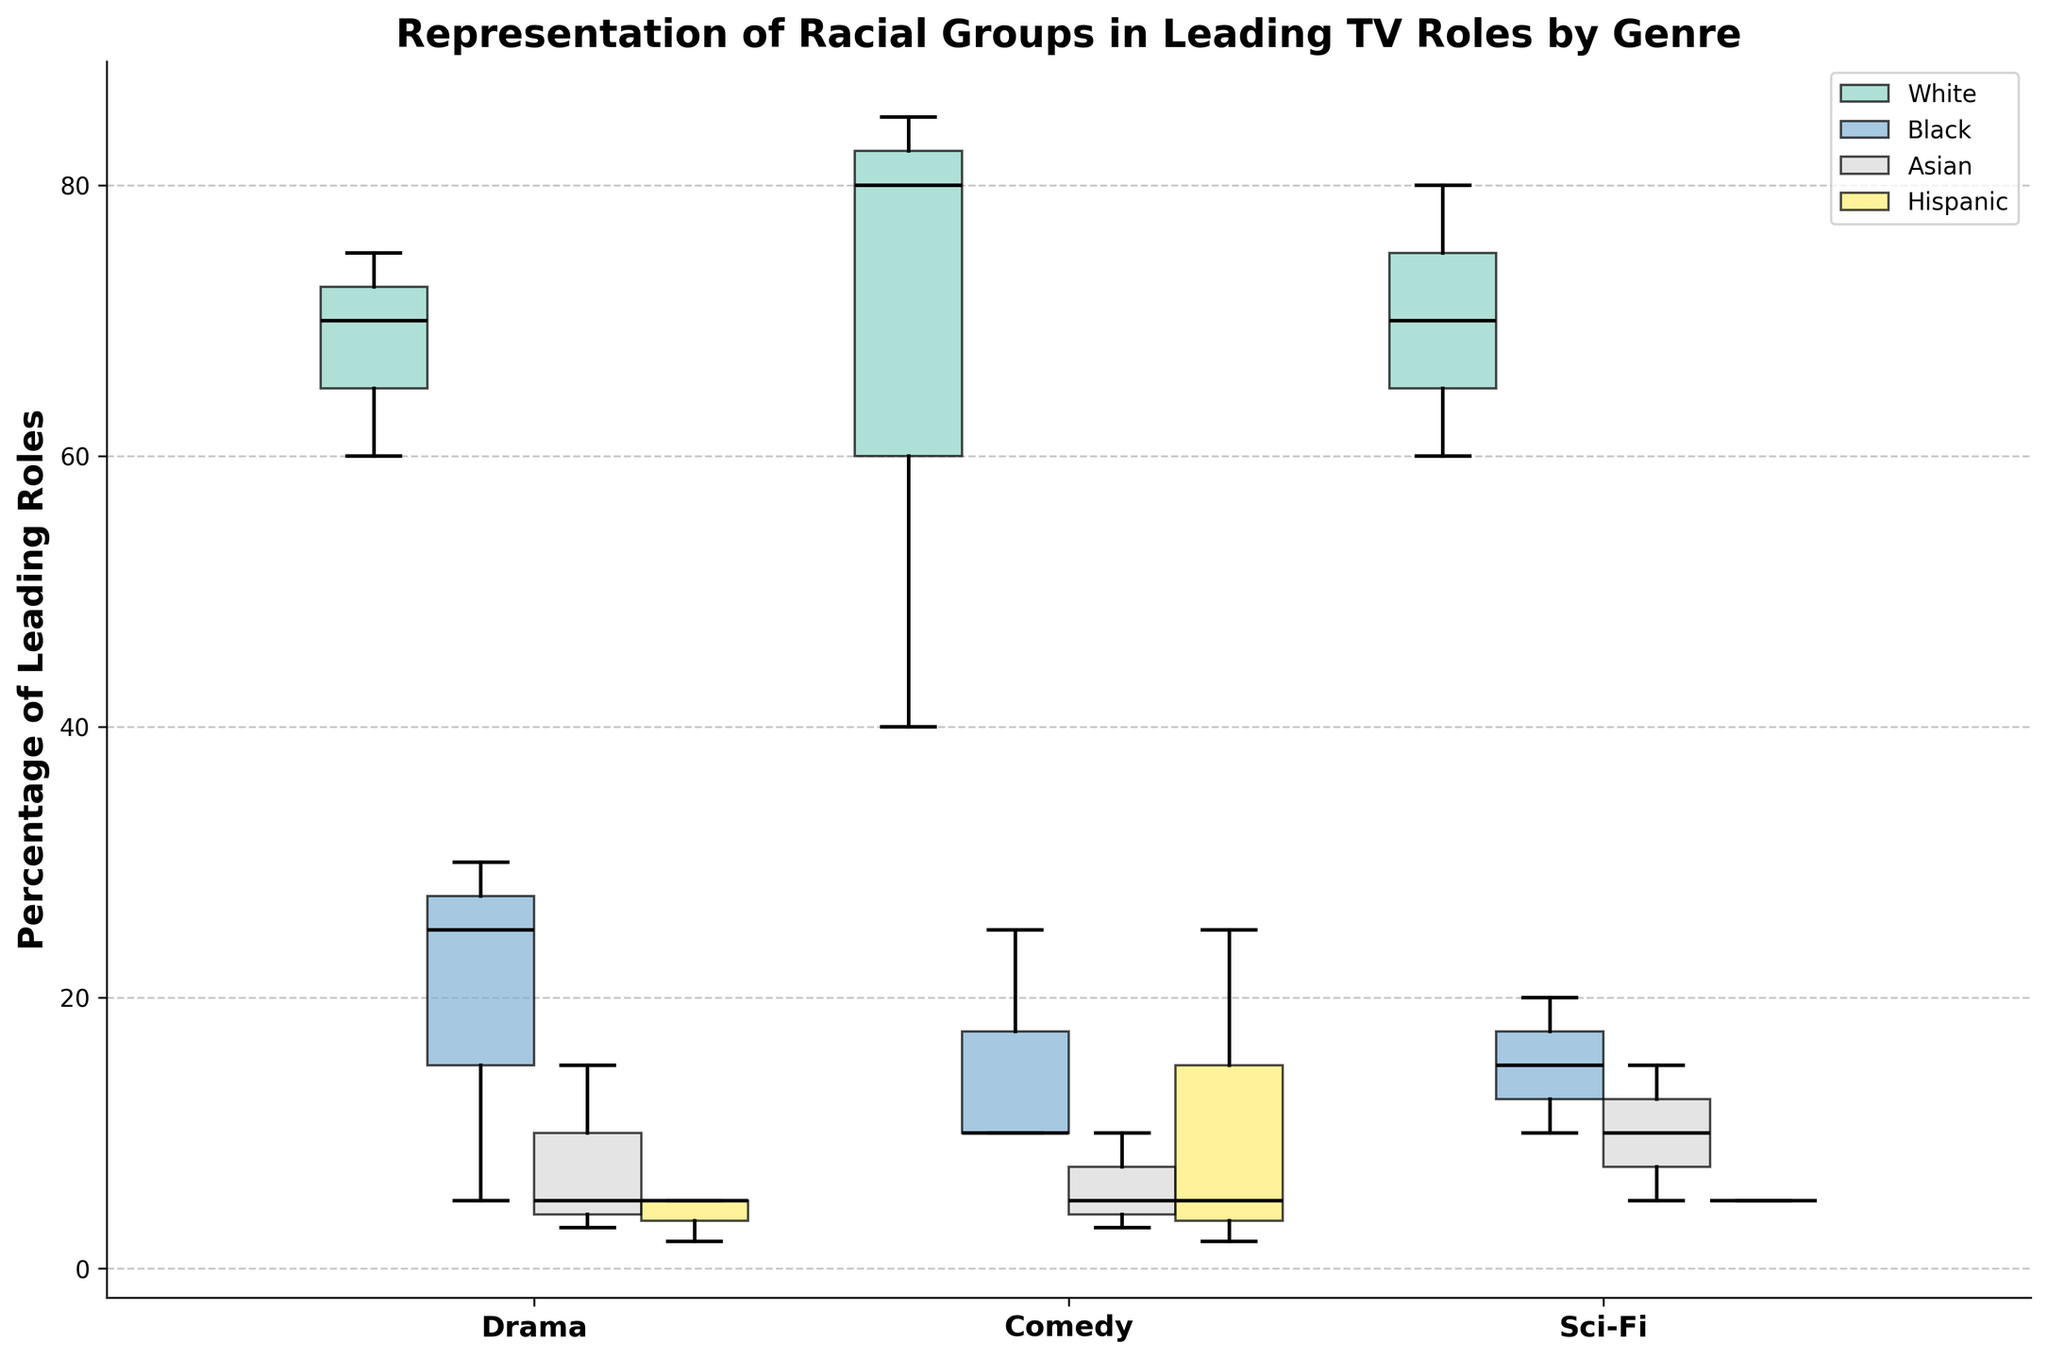what's the title of the chart? The title of the chart is located at the top and summarizes the main topic of the chart. Here, it reads "Representation of Racial Groups in Leading TV Roles by Genre".
Answer: Representation of Racial Groups in Leading TV Roles by Genre Which genre shows the highest median percentage for White leading roles? By examining the median lines inside the plots for each genre, the highest one can be identified in the "Comedy" genre.
Answer: Comedy Which racial group has the smallest range of values across all genres? To find the smallest range, we need to look at the distance between the whiskers of each box for all racial groups and compare. The "Hispanic" group's ranges are quite consistently small.
Answer: Hispanic What is the interquartile range (IQR) for Black leading roles in the Sci-Fi genre? The IQR is found by subtracting the 25th percentile (lower quartile) from the 75th percentile (upper quartile). For Black leading roles in Sci-Fi, the lower quartile is approximately 10% and the upper quartile is approximately 20%. Thus, IQR = 20% - 10%.
Answer: 10% Which genre appears to have the most balanced representation of racial groups? By comparing the boxes' locations and sizes for each genre, "Comedy" seems to have a closer distribution of percentages among different racial groups compared to other genres.
Answer: Comedy How does the median percentage of Black leading roles in Drama compare to that in Sci-Fi? To compare medians, we check the median lines in the boxes. In Drama, it’s around 25%, whereas in Sci-Fi, it’s around 15%. Drama's median is higher.
Answer: Drama's median is higher What can be inferred about the representation of Asian leading roles in Comedy genre? The median line for Asian roles in Comedy is relatively low, and the range (box) is also small, suggesting a low and consistent representation.
Answer: Low and consistent For the White racial group, which genre exhibits the highest variability? Variability is indicated by the length of the whiskers and the spread of the boxes. The “Comedy” genre shows the greatest spread in its box plot for the White racial group.
Answer: Comedy Approximately, what is the median percentage of Hispanic leading roles in Drama? The median is represented by the line within the box for Hispanic roles in the Drama genre. It’s around 5%.
Answer: 5% 